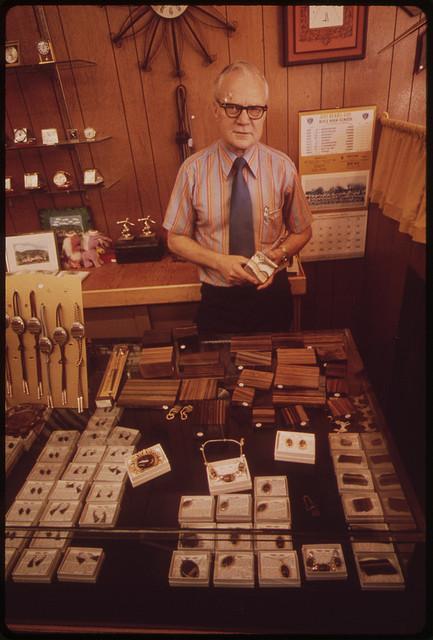How many people are in the photo?
Give a very brief answer. 1. How many cats have gray on their fur?
Give a very brief answer. 0. 